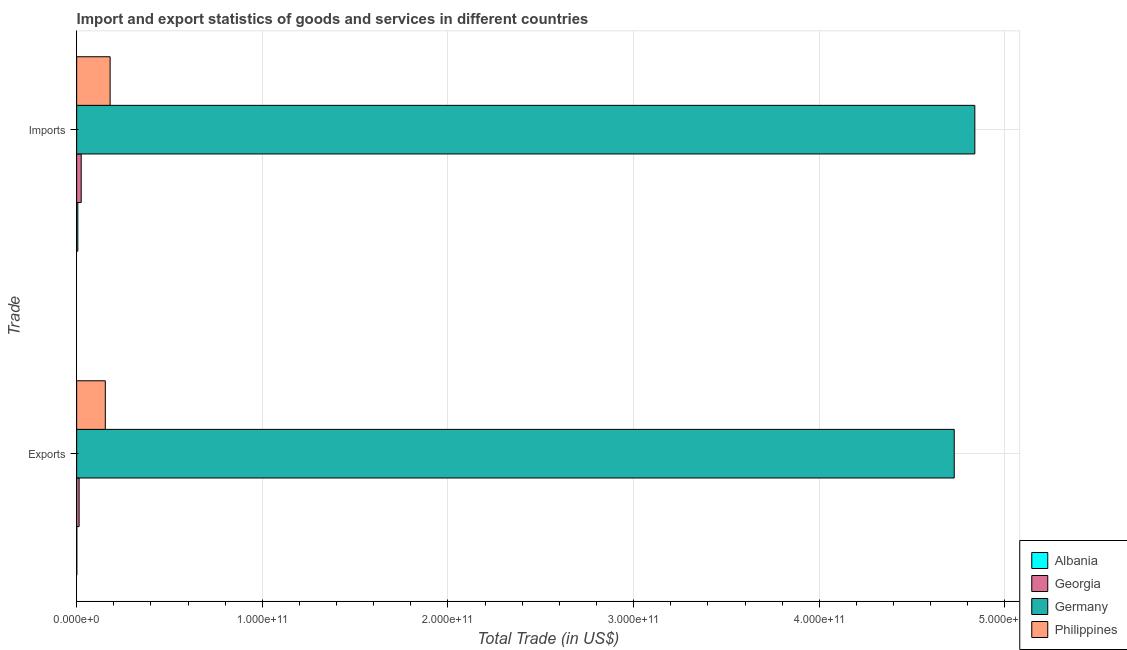How many different coloured bars are there?
Offer a very short reply. 4. How many groups of bars are there?
Your answer should be very brief. 2. Are the number of bars per tick equal to the number of legend labels?
Keep it short and to the point. Yes. How many bars are there on the 2nd tick from the top?
Provide a short and direct response. 4. What is the label of the 1st group of bars from the top?
Provide a short and direct response. Imports. What is the imports of goods and services in Georgia?
Your answer should be very brief. 2.45e+09. Across all countries, what is the maximum export of goods and services?
Provide a succinct answer. 4.73e+11. Across all countries, what is the minimum export of goods and services?
Your answer should be compact. 8.15e+07. In which country was the imports of goods and services minimum?
Give a very brief answer. Albania. What is the total imports of goods and services in the graph?
Keep it short and to the point. 5.05e+11. What is the difference between the export of goods and services in Albania and that in Germany?
Provide a short and direct response. -4.73e+11. What is the difference between the export of goods and services in Philippines and the imports of goods and services in Germany?
Your answer should be compact. -4.68e+11. What is the average imports of goods and services per country?
Ensure brevity in your answer.  1.26e+11. What is the difference between the imports of goods and services and export of goods and services in Georgia?
Your answer should be very brief. 1.13e+09. In how many countries, is the imports of goods and services greater than 120000000000 US$?
Provide a short and direct response. 1. What is the ratio of the imports of goods and services in Philippines to that in Germany?
Make the answer very short. 0.04. Is the imports of goods and services in Germany less than that in Philippines?
Offer a terse response. No. What does the 2nd bar from the bottom in Imports represents?
Your answer should be compact. Georgia. Are all the bars in the graph horizontal?
Offer a very short reply. Yes. What is the difference between two consecutive major ticks on the X-axis?
Your response must be concise. 1.00e+11. Does the graph contain grids?
Your answer should be very brief. Yes. How are the legend labels stacked?
Keep it short and to the point. Vertical. What is the title of the graph?
Your answer should be compact. Import and export statistics of goods and services in different countries. What is the label or title of the X-axis?
Give a very brief answer. Total Trade (in US$). What is the label or title of the Y-axis?
Provide a succinct answer. Trade. What is the Total Trade (in US$) of Albania in Exports?
Your response must be concise. 8.15e+07. What is the Total Trade (in US$) of Georgia in Exports?
Offer a terse response. 1.32e+09. What is the Total Trade (in US$) of Germany in Exports?
Provide a short and direct response. 4.73e+11. What is the Total Trade (in US$) of Philippines in Exports?
Offer a very short reply. 1.54e+1. What is the Total Trade (in US$) in Albania in Imports?
Give a very brief answer. 6.28e+08. What is the Total Trade (in US$) of Georgia in Imports?
Make the answer very short. 2.45e+09. What is the Total Trade (in US$) in Germany in Imports?
Your answer should be very brief. 4.84e+11. What is the Total Trade (in US$) in Philippines in Imports?
Keep it short and to the point. 1.80e+1. Across all Trade, what is the maximum Total Trade (in US$) in Albania?
Keep it short and to the point. 6.28e+08. Across all Trade, what is the maximum Total Trade (in US$) of Georgia?
Your answer should be compact. 2.45e+09. Across all Trade, what is the maximum Total Trade (in US$) of Germany?
Keep it short and to the point. 4.84e+11. Across all Trade, what is the maximum Total Trade (in US$) in Philippines?
Give a very brief answer. 1.80e+1. Across all Trade, what is the minimum Total Trade (in US$) of Albania?
Give a very brief answer. 8.15e+07. Across all Trade, what is the minimum Total Trade (in US$) of Georgia?
Ensure brevity in your answer.  1.32e+09. Across all Trade, what is the minimum Total Trade (in US$) of Germany?
Keep it short and to the point. 4.73e+11. Across all Trade, what is the minimum Total Trade (in US$) of Philippines?
Your response must be concise. 1.54e+1. What is the total Total Trade (in US$) of Albania in the graph?
Provide a succinct answer. 7.09e+08. What is the total Total Trade (in US$) of Georgia in the graph?
Offer a terse response. 3.76e+09. What is the total Total Trade (in US$) of Germany in the graph?
Provide a succinct answer. 9.56e+11. What is the total Total Trade (in US$) of Philippines in the graph?
Provide a succinct answer. 3.35e+1. What is the difference between the Total Trade (in US$) in Albania in Exports and that in Imports?
Provide a succinct answer. -5.46e+08. What is the difference between the Total Trade (in US$) in Georgia in Exports and that in Imports?
Provide a succinct answer. -1.13e+09. What is the difference between the Total Trade (in US$) in Germany in Exports and that in Imports?
Make the answer very short. -1.11e+1. What is the difference between the Total Trade (in US$) in Philippines in Exports and that in Imports?
Provide a succinct answer. -2.60e+09. What is the difference between the Total Trade (in US$) of Albania in Exports and the Total Trade (in US$) of Georgia in Imports?
Keep it short and to the point. -2.36e+09. What is the difference between the Total Trade (in US$) of Albania in Exports and the Total Trade (in US$) of Germany in Imports?
Make the answer very short. -4.84e+11. What is the difference between the Total Trade (in US$) of Albania in Exports and the Total Trade (in US$) of Philippines in Imports?
Offer a terse response. -1.79e+1. What is the difference between the Total Trade (in US$) of Georgia in Exports and the Total Trade (in US$) of Germany in Imports?
Your answer should be compact. -4.82e+11. What is the difference between the Total Trade (in US$) in Georgia in Exports and the Total Trade (in US$) in Philippines in Imports?
Keep it short and to the point. -1.67e+1. What is the difference between the Total Trade (in US$) of Germany in Exports and the Total Trade (in US$) of Philippines in Imports?
Your response must be concise. 4.55e+11. What is the average Total Trade (in US$) in Albania per Trade?
Offer a very short reply. 3.55e+08. What is the average Total Trade (in US$) of Georgia per Trade?
Keep it short and to the point. 1.88e+09. What is the average Total Trade (in US$) of Germany per Trade?
Offer a very short reply. 4.78e+11. What is the average Total Trade (in US$) in Philippines per Trade?
Give a very brief answer. 1.67e+1. What is the difference between the Total Trade (in US$) of Albania and Total Trade (in US$) of Georgia in Exports?
Offer a terse response. -1.23e+09. What is the difference between the Total Trade (in US$) of Albania and Total Trade (in US$) of Germany in Exports?
Your answer should be compact. -4.73e+11. What is the difference between the Total Trade (in US$) of Albania and Total Trade (in US$) of Philippines in Exports?
Keep it short and to the point. -1.54e+1. What is the difference between the Total Trade (in US$) of Georgia and Total Trade (in US$) of Germany in Exports?
Your answer should be very brief. -4.71e+11. What is the difference between the Total Trade (in US$) in Georgia and Total Trade (in US$) in Philippines in Exports?
Offer a terse response. -1.41e+1. What is the difference between the Total Trade (in US$) of Germany and Total Trade (in US$) of Philippines in Exports?
Give a very brief answer. 4.57e+11. What is the difference between the Total Trade (in US$) of Albania and Total Trade (in US$) of Georgia in Imports?
Give a very brief answer. -1.82e+09. What is the difference between the Total Trade (in US$) in Albania and Total Trade (in US$) in Germany in Imports?
Offer a very short reply. -4.83e+11. What is the difference between the Total Trade (in US$) of Albania and Total Trade (in US$) of Philippines in Imports?
Your response must be concise. -1.74e+1. What is the difference between the Total Trade (in US$) of Georgia and Total Trade (in US$) of Germany in Imports?
Offer a terse response. -4.81e+11. What is the difference between the Total Trade (in US$) of Georgia and Total Trade (in US$) of Philippines in Imports?
Make the answer very short. -1.56e+1. What is the difference between the Total Trade (in US$) of Germany and Total Trade (in US$) of Philippines in Imports?
Offer a terse response. 4.66e+11. What is the ratio of the Total Trade (in US$) in Albania in Exports to that in Imports?
Make the answer very short. 0.13. What is the ratio of the Total Trade (in US$) of Georgia in Exports to that in Imports?
Ensure brevity in your answer.  0.54. What is the ratio of the Total Trade (in US$) of Germany in Exports to that in Imports?
Make the answer very short. 0.98. What is the ratio of the Total Trade (in US$) in Philippines in Exports to that in Imports?
Offer a terse response. 0.86. What is the difference between the highest and the second highest Total Trade (in US$) in Albania?
Keep it short and to the point. 5.46e+08. What is the difference between the highest and the second highest Total Trade (in US$) of Georgia?
Your answer should be compact. 1.13e+09. What is the difference between the highest and the second highest Total Trade (in US$) in Germany?
Provide a succinct answer. 1.11e+1. What is the difference between the highest and the second highest Total Trade (in US$) of Philippines?
Provide a short and direct response. 2.60e+09. What is the difference between the highest and the lowest Total Trade (in US$) of Albania?
Offer a terse response. 5.46e+08. What is the difference between the highest and the lowest Total Trade (in US$) in Georgia?
Your answer should be very brief. 1.13e+09. What is the difference between the highest and the lowest Total Trade (in US$) of Germany?
Offer a very short reply. 1.11e+1. What is the difference between the highest and the lowest Total Trade (in US$) of Philippines?
Make the answer very short. 2.60e+09. 